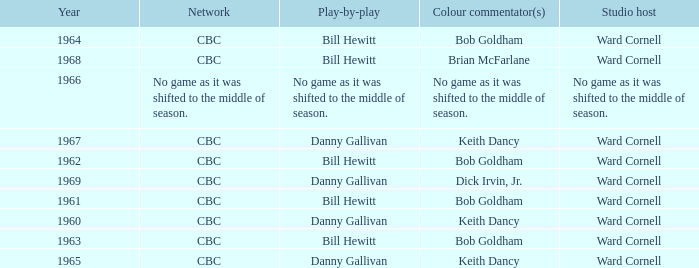Who gave the play by play commentary with studio host Ward Cornell? Danny Gallivan, Bill Hewitt, Danny Gallivan, Danny Gallivan, Bill Hewitt, Bill Hewitt, Bill Hewitt, Bill Hewitt, Danny Gallivan. Would you mind parsing the complete table? {'header': ['Year', 'Network', 'Play-by-play', 'Colour commentator(s)', 'Studio host'], 'rows': [['1964', 'CBC', 'Bill Hewitt', 'Bob Goldham', 'Ward Cornell'], ['1968', 'CBC', 'Bill Hewitt', 'Brian McFarlane', 'Ward Cornell'], ['1966', 'No game as it was shifted to the middle of season.', 'No game as it was shifted to the middle of season.', 'No game as it was shifted to the middle of season.', 'No game as it was shifted to the middle of season.'], ['1967', 'CBC', 'Danny Gallivan', 'Keith Dancy', 'Ward Cornell'], ['1962', 'CBC', 'Bill Hewitt', 'Bob Goldham', 'Ward Cornell'], ['1969', 'CBC', 'Danny Gallivan', 'Dick Irvin, Jr.', 'Ward Cornell'], ['1961', 'CBC', 'Bill Hewitt', 'Bob Goldham', 'Ward Cornell'], ['1960', 'CBC', 'Danny Gallivan', 'Keith Dancy', 'Ward Cornell'], ['1963', 'CBC', 'Bill Hewitt', 'Bob Goldham', 'Ward Cornell'], ['1965', 'CBC', 'Danny Gallivan', 'Keith Dancy', 'Ward Cornell']]} 